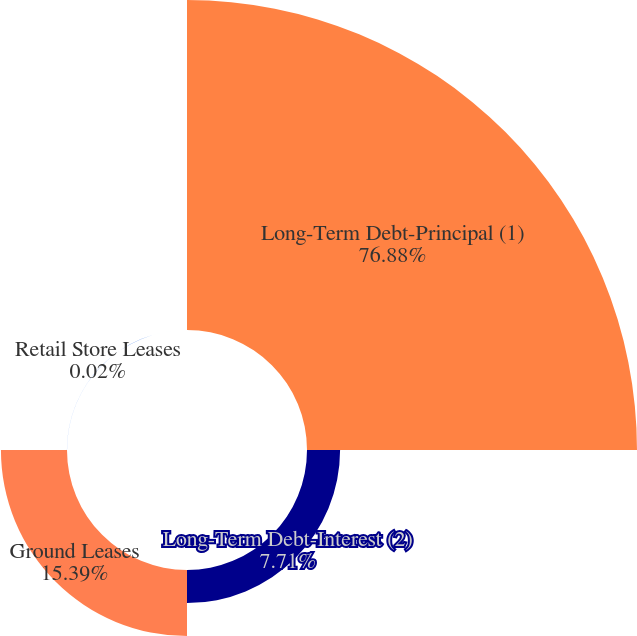Convert chart. <chart><loc_0><loc_0><loc_500><loc_500><pie_chart><fcel>Long-Term Debt-Principal (1)<fcel>Long-Term Debt-Interest (2)<fcel>Ground Leases<fcel>Retail Store Leases<nl><fcel>76.88%<fcel>7.71%<fcel>15.39%<fcel>0.02%<nl></chart> 